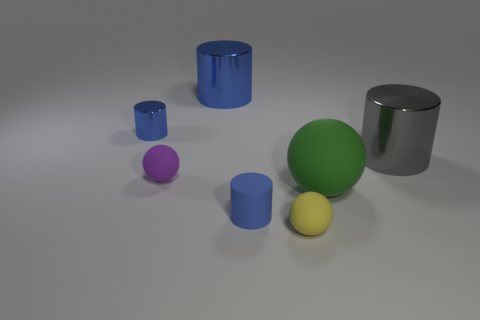Subtract all blue spheres. How many blue cylinders are left? 3 Add 3 large gray shiny cubes. How many objects exist? 10 Subtract all cylinders. How many objects are left? 3 Subtract all large gray things. Subtract all tiny metal cylinders. How many objects are left? 5 Add 3 big rubber spheres. How many big rubber spheres are left? 4 Add 7 yellow cubes. How many yellow cubes exist? 7 Subtract 0 brown spheres. How many objects are left? 7 